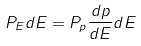Convert formula to latex. <formula><loc_0><loc_0><loc_500><loc_500>P _ { E } d E = P _ { p } \frac { d p } { d E } d E</formula> 